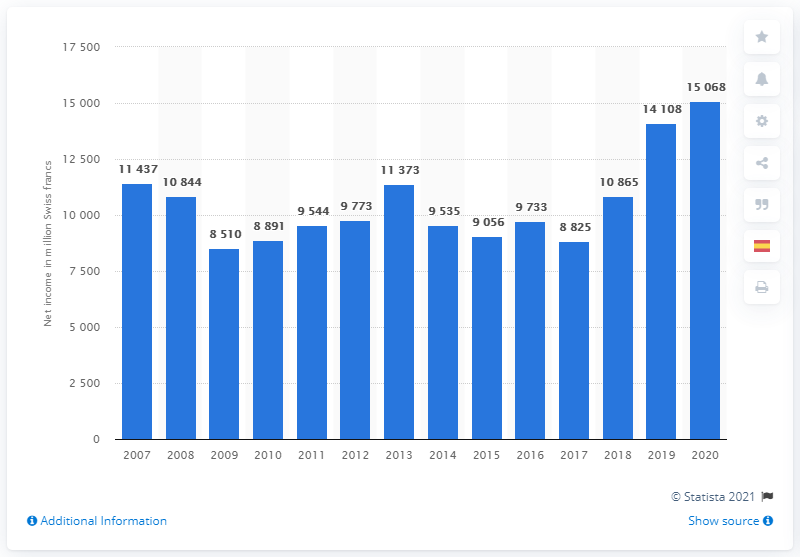Mention a couple of crucial points in this snapshot. Roche reported a net income of 15,068 Swiss francs in 2020. 